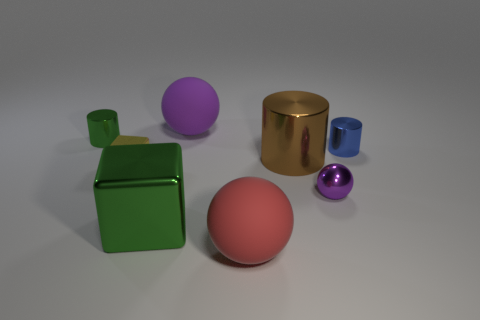Subtract 2 cylinders. How many cylinders are left? 1 Add 1 red rubber cylinders. How many objects exist? 9 Subtract all big cylinders. How many cylinders are left? 2 Subtract 0 red blocks. How many objects are left? 8 Subtract all balls. How many objects are left? 5 Subtract all blue cylinders. Subtract all brown cubes. How many cylinders are left? 2 Subtract all brown spheres. How many gray blocks are left? 0 Subtract all small red cubes. Subtract all tiny yellow blocks. How many objects are left? 7 Add 1 small yellow cubes. How many small yellow cubes are left? 2 Add 8 large blue metallic spheres. How many large blue metallic spheres exist? 8 